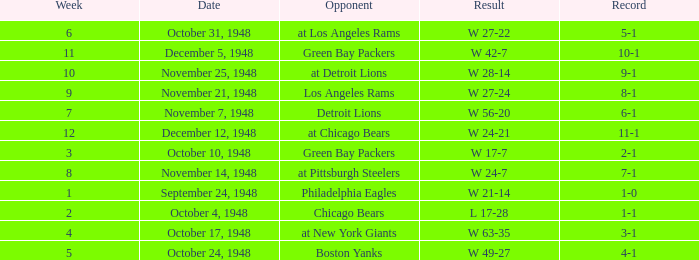Give me the full table as a dictionary. {'header': ['Week', 'Date', 'Opponent', 'Result', 'Record'], 'rows': [['6', 'October 31, 1948', 'at Los Angeles Rams', 'W 27-22', '5-1'], ['11', 'December 5, 1948', 'Green Bay Packers', 'W 42-7', '10-1'], ['10', 'November 25, 1948', 'at Detroit Lions', 'W 28-14', '9-1'], ['9', 'November 21, 1948', 'Los Angeles Rams', 'W 27-24', '8-1'], ['7', 'November 7, 1948', 'Detroit Lions', 'W 56-20', '6-1'], ['12', 'December 12, 1948', 'at Chicago Bears', 'W 24-21', '11-1'], ['3', 'October 10, 1948', 'Green Bay Packers', 'W 17-7', '2-1'], ['8', 'November 14, 1948', 'at Pittsburgh Steelers', 'W 24-7', '7-1'], ['1', 'September 24, 1948', 'Philadelphia Eagles', 'W 21-14', '1-0'], ['2', 'October 4, 1948', 'Chicago Bears', 'L 17-28', '1-1'], ['4', 'October 17, 1948', 'at New York Giants', 'W 63-35', '3-1'], ['5', 'October 24, 1948', 'Boston Yanks', 'W 49-27', '4-1']]} What was the record for December 5, 1948? 10-1. 